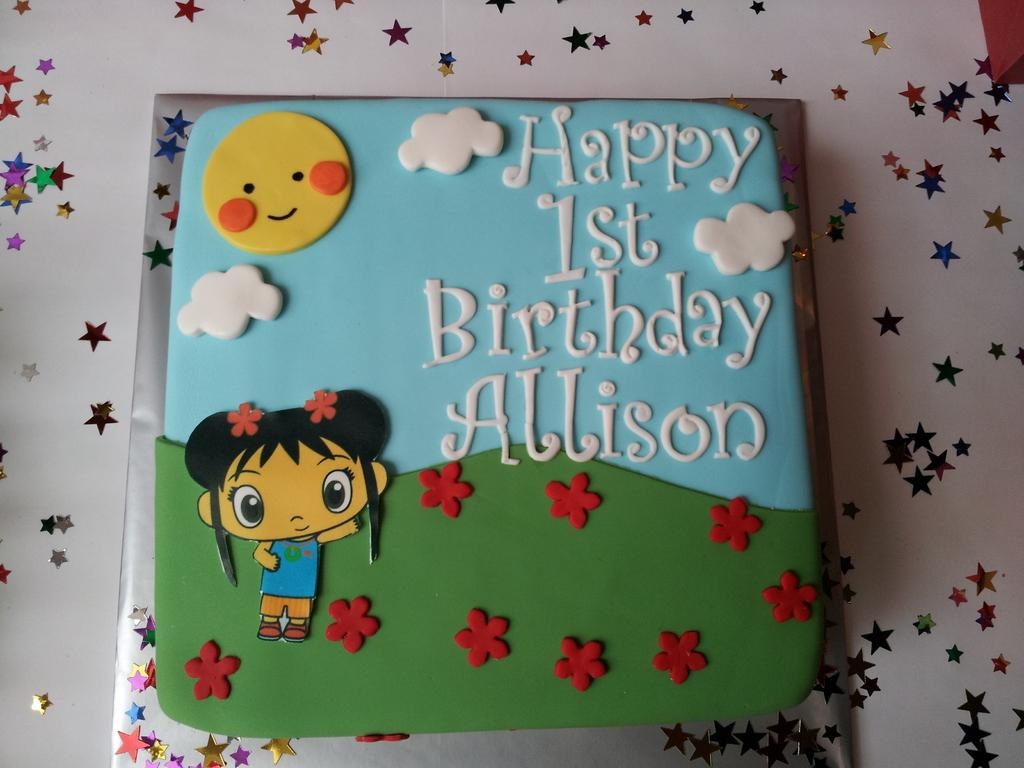What is the main subject of the picture? The main subject of the picture is a cake. What colors are used to decorate the cake? The cake has two different colors: green and blue. What type of images are on the cake? There are cartoon images on the cake. What decorations are attached to the cake? There are stars attached to the cake. What government policy is being discussed in relation to the cake? There is no discussion of government policy in the image, as it features a cake with cartoon images and stars. What adjustments need to be made to the cake before serving? The image does not provide any information about adjustments needed for serving the cake. 